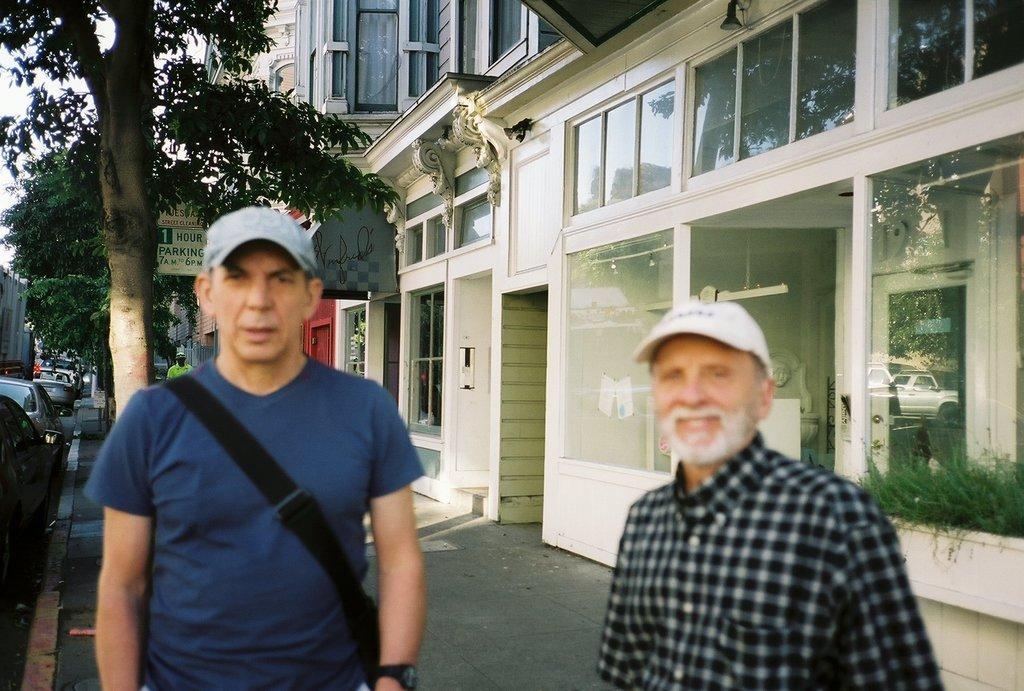Please provide a concise description of this image. To the left side on the road there are few cars. Beside the road there is a footpath. To the left side here is a man with a blue t-shirt, black bag and a cap on his head is standing. Beside him there is another man with black and white checks shirt and a cap on his head is standing. Behind them there is a building with glass windows, doors, stores and trees on the footpath. And also there is a poster to the tree. 